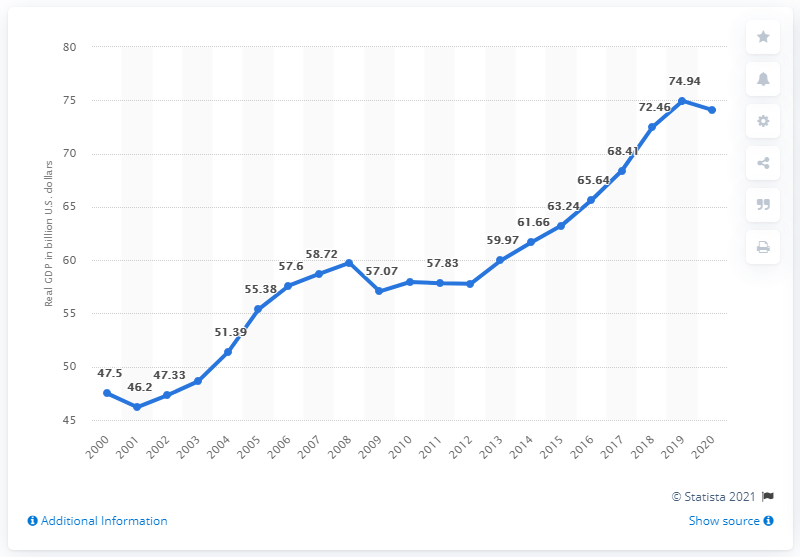Indicate a few pertinent items in this graphic. In 2020, the Gross Domestic Product (GDP) of Idaho was 74.08. In the previous year, the Gross Domestic Product (GDP) of Idaho was $74.94 billion. 